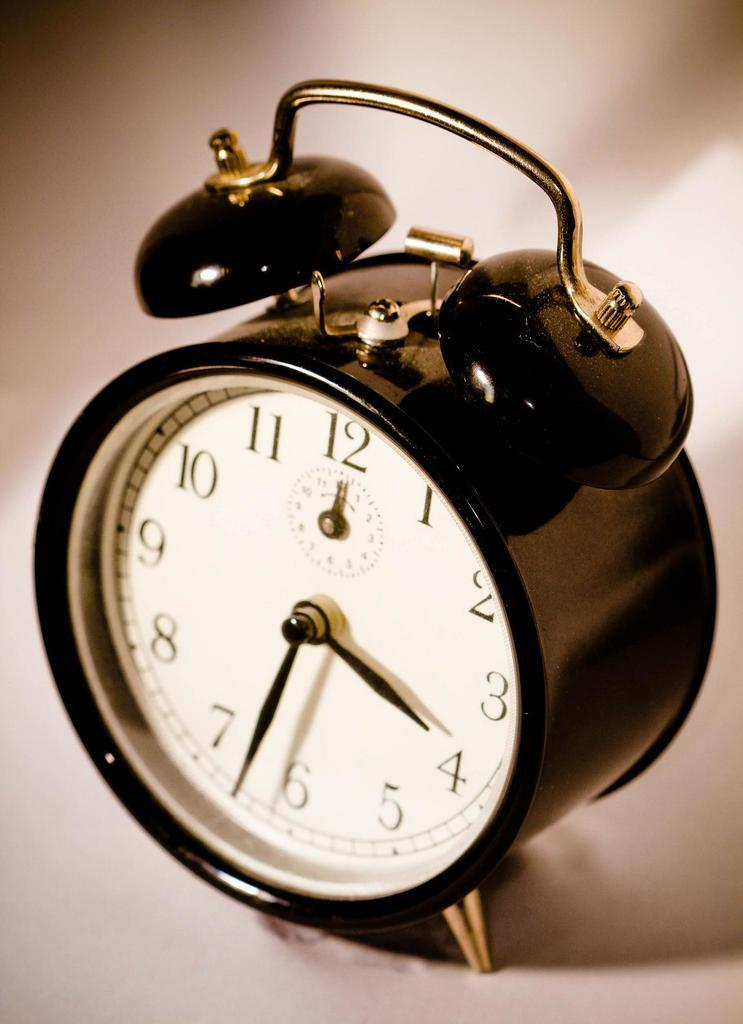<image>
Summarize the visual content of the image. An old bell clock points to the numbers 4 and 6 